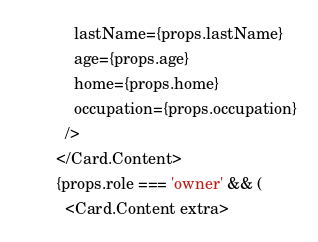Convert code to text. <code><loc_0><loc_0><loc_500><loc_500><_JavaScript_>        lastName={props.lastName}
        age={props.age}
        home={props.home}
        occupation={props.occupation}
      />
    </Card.Content>
    {props.role === 'owner' && (
      <Card.Content extra></code> 